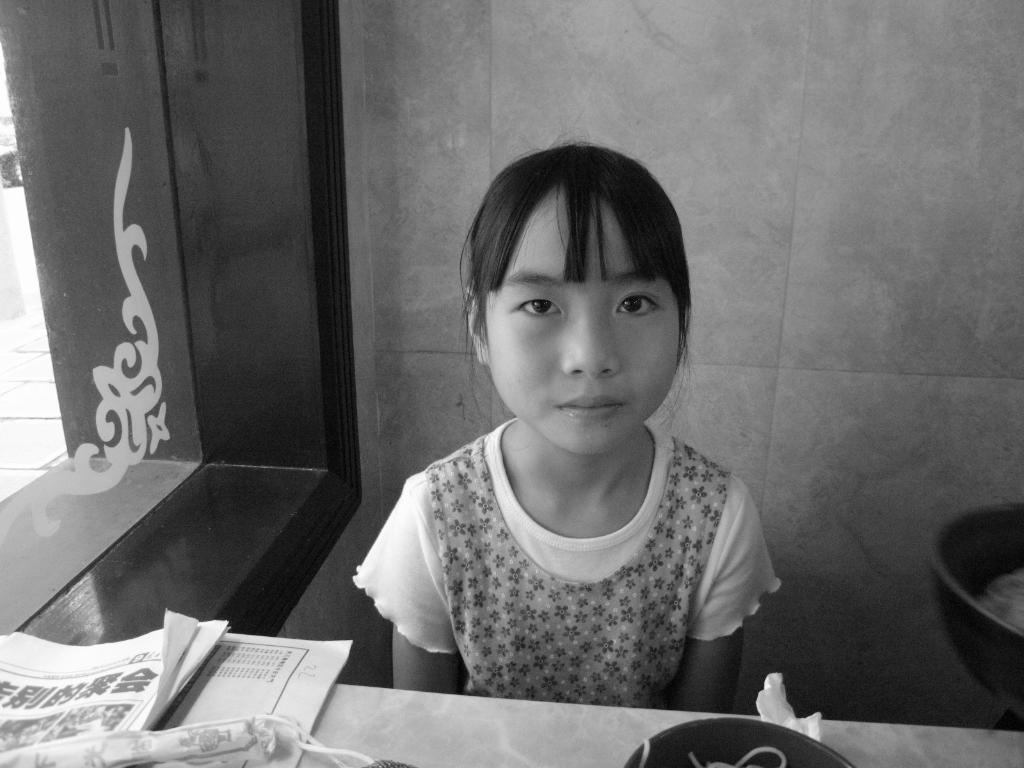In one or two sentences, can you explain what this image depicts? A girl is present. She has bangs. There are papers at the front and a glass window on the left. 